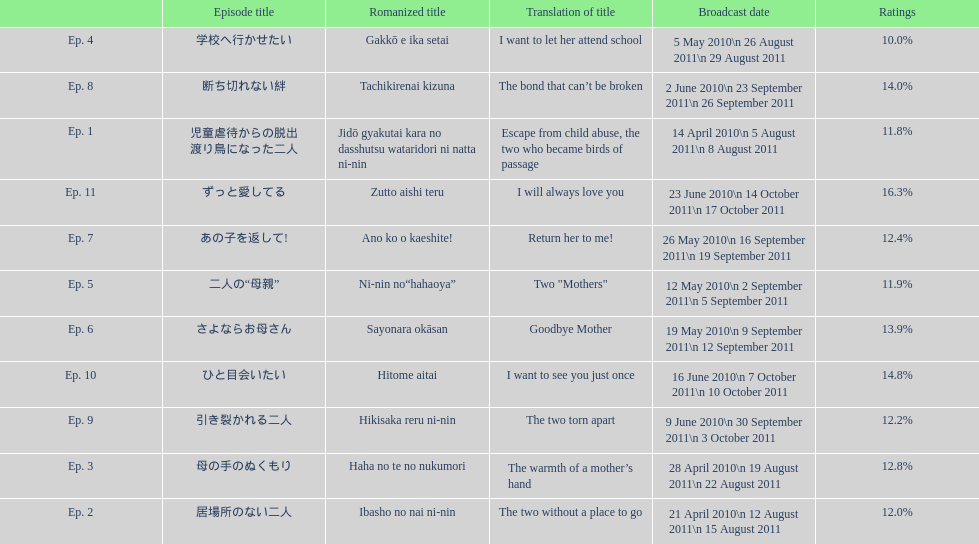What are all of the episode numbers? Ep. 1, Ep. 2, Ep. 3, Ep. 4, Ep. 5, Ep. 6, Ep. 7, Ep. 8, Ep. 9, Ep. 10, Ep. 11. And their titles? 児童虐待からの脱出 渡り鳥になった二人, 居場所のない二人, 母の手のぬくもり, 学校へ行かせたい, 二人の“母親”, さよならお母さん, あの子を返して!, 断ち切れない絆, 引き裂かれる二人, ひと目会いたい, ずっと愛してる. What about their translated names? Escape from child abuse, the two who became birds of passage, The two without a place to go, The warmth of a mother’s hand, I want to let her attend school, Two "Mothers", Goodbye Mother, Return her to me!, The bond that can’t be broken, The two torn apart, I want to see you just once, I will always love you. Which episode number's title translated to i want to let her attend school? Ep. 4. 